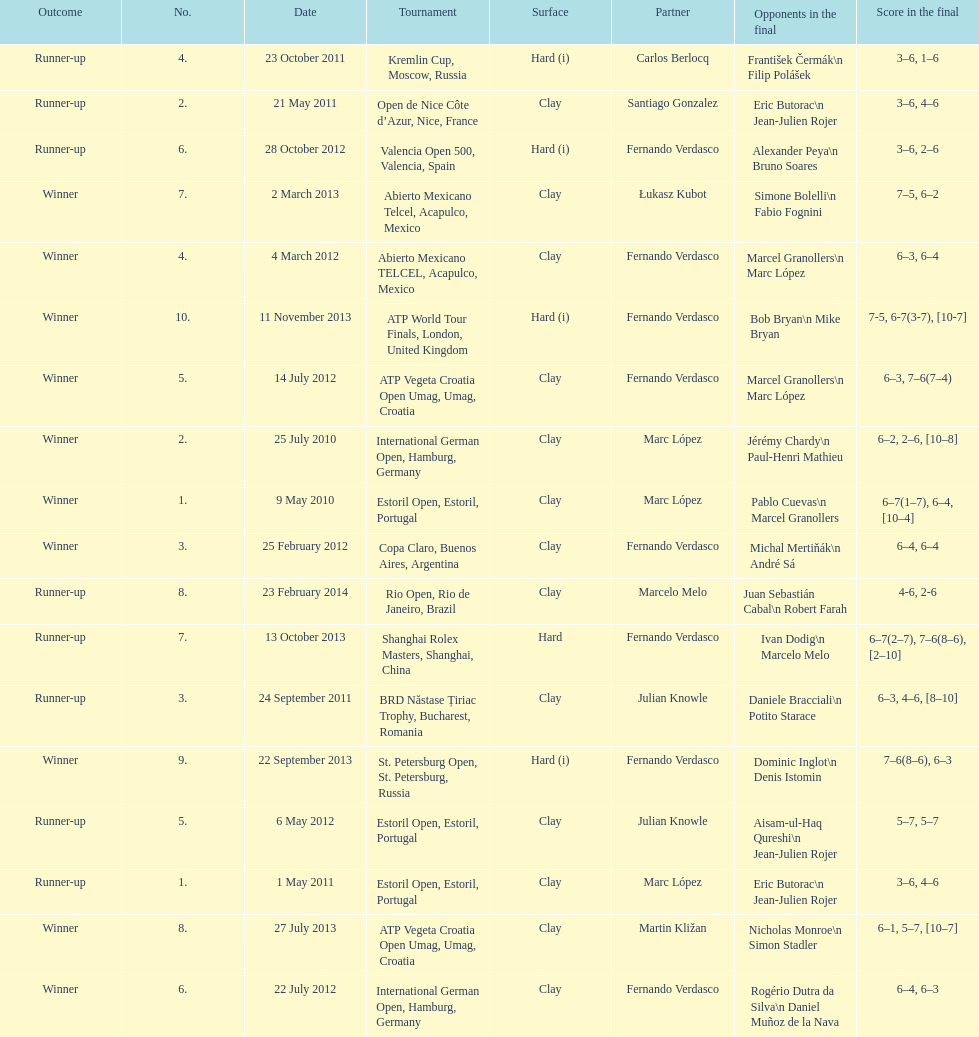I'm looking to parse the entire table for insights. Could you assist me with that? {'header': ['Outcome', 'No.', 'Date', 'Tournament', 'Surface', 'Partner', 'Opponents in the final', 'Score in the final'], 'rows': [['Runner-up', '4.', '23 October 2011', 'Kremlin Cup, Moscow, Russia', 'Hard (i)', 'Carlos Berlocq', 'František Čermák\\n Filip Polášek', '3–6, 1–6'], ['Runner-up', '2.', '21 May 2011', 'Open de Nice Côte d’Azur, Nice, France', 'Clay', 'Santiago Gonzalez', 'Eric Butorac\\n Jean-Julien Rojer', '3–6, 4–6'], ['Runner-up', '6.', '28 October 2012', 'Valencia Open 500, Valencia, Spain', 'Hard (i)', 'Fernando Verdasco', 'Alexander Peya\\n Bruno Soares', '3–6, 2–6'], ['Winner', '7.', '2 March 2013', 'Abierto Mexicano Telcel, Acapulco, Mexico', 'Clay', 'Łukasz Kubot', 'Simone Bolelli\\n Fabio Fognini', '7–5, 6–2'], ['Winner', '4.', '4 March 2012', 'Abierto Mexicano TELCEL, Acapulco, Mexico', 'Clay', 'Fernando Verdasco', 'Marcel Granollers\\n Marc López', '6–3, 6–4'], ['Winner', '10.', '11 November 2013', 'ATP World Tour Finals, London, United Kingdom', 'Hard (i)', 'Fernando Verdasco', 'Bob Bryan\\n Mike Bryan', '7-5, 6-7(3-7), [10-7]'], ['Winner', '5.', '14 July 2012', 'ATP Vegeta Croatia Open Umag, Umag, Croatia', 'Clay', 'Fernando Verdasco', 'Marcel Granollers\\n Marc López', '6–3, 7–6(7–4)'], ['Winner', '2.', '25 July 2010', 'International German Open, Hamburg, Germany', 'Clay', 'Marc López', 'Jérémy Chardy\\n Paul-Henri Mathieu', '6–2, 2–6, [10–8]'], ['Winner', '1.', '9 May 2010', 'Estoril Open, Estoril, Portugal', 'Clay', 'Marc López', 'Pablo Cuevas\\n Marcel Granollers', '6–7(1–7), 6–4, [10–4]'], ['Winner', '3.', '25 February 2012', 'Copa Claro, Buenos Aires, Argentina', 'Clay', 'Fernando Verdasco', 'Michal Mertiňák\\n André Sá', '6–4, 6–4'], ['Runner-up', '8.', '23 February 2014', 'Rio Open, Rio de Janeiro, Brazil', 'Clay', 'Marcelo Melo', 'Juan Sebastián Cabal\\n Robert Farah', '4-6, 2-6'], ['Runner-up', '7.', '13 October 2013', 'Shanghai Rolex Masters, Shanghai, China', 'Hard', 'Fernando Verdasco', 'Ivan Dodig\\n Marcelo Melo', '6–7(2–7), 7–6(8–6), [2–10]'], ['Runner-up', '3.', '24 September 2011', 'BRD Năstase Țiriac Trophy, Bucharest, Romania', 'Clay', 'Julian Knowle', 'Daniele Bracciali\\n Potito Starace', '6–3, 4–6, [8–10]'], ['Winner', '9.', '22 September 2013', 'St. Petersburg Open, St. Petersburg, Russia', 'Hard (i)', 'Fernando Verdasco', 'Dominic Inglot\\n Denis Istomin', '7–6(8–6), 6–3'], ['Runner-up', '5.', '6 May 2012', 'Estoril Open, Estoril, Portugal', 'Clay', 'Julian Knowle', 'Aisam-ul-Haq Qureshi\\n Jean-Julien Rojer', '5–7, 5–7'], ['Runner-up', '1.', '1 May 2011', 'Estoril Open, Estoril, Portugal', 'Clay', 'Marc López', 'Eric Butorac\\n Jean-Julien Rojer', '3–6, 4–6'], ['Winner', '8.', '27 July 2013', 'ATP Vegeta Croatia Open Umag, Umag, Croatia', 'Clay', 'Martin Kližan', 'Nicholas Monroe\\n Simon Stadler', '6–1, 5–7, [10–7]'], ['Winner', '6.', '22 July 2012', 'International German Open, Hamburg, Germany', 'Clay', 'Fernando Verdasco', 'Rogério Dutra da Silva\\n Daniel Muñoz de la Nava', '6–4, 6–3']]} How many partners from spain are listed? 2. 